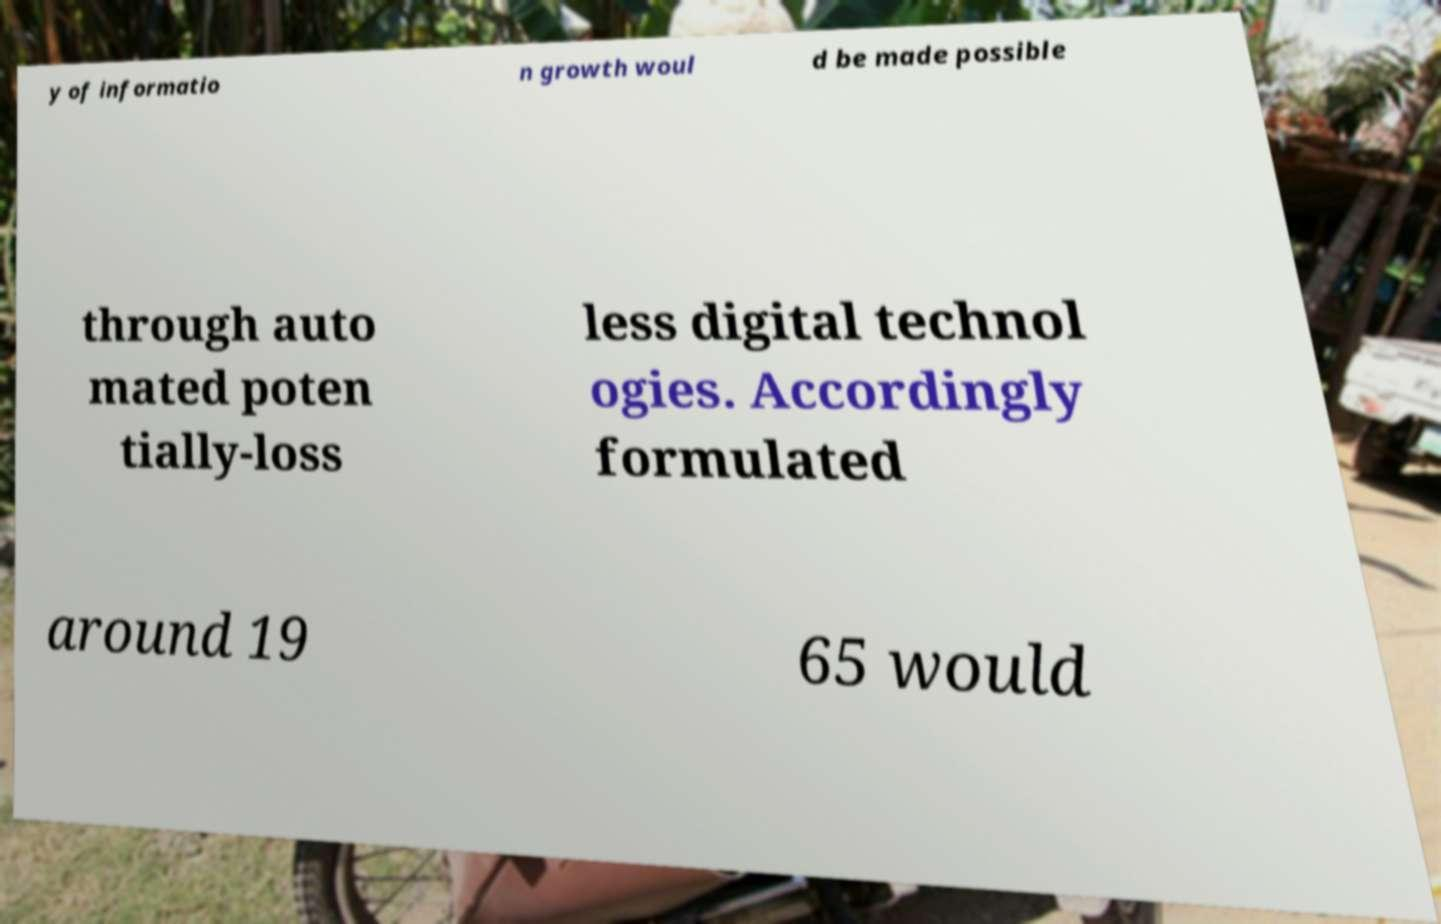What messages or text are displayed in this image? I need them in a readable, typed format. y of informatio n growth woul d be made possible through auto mated poten tially-loss less digital technol ogies. Accordingly formulated around 19 65 would 